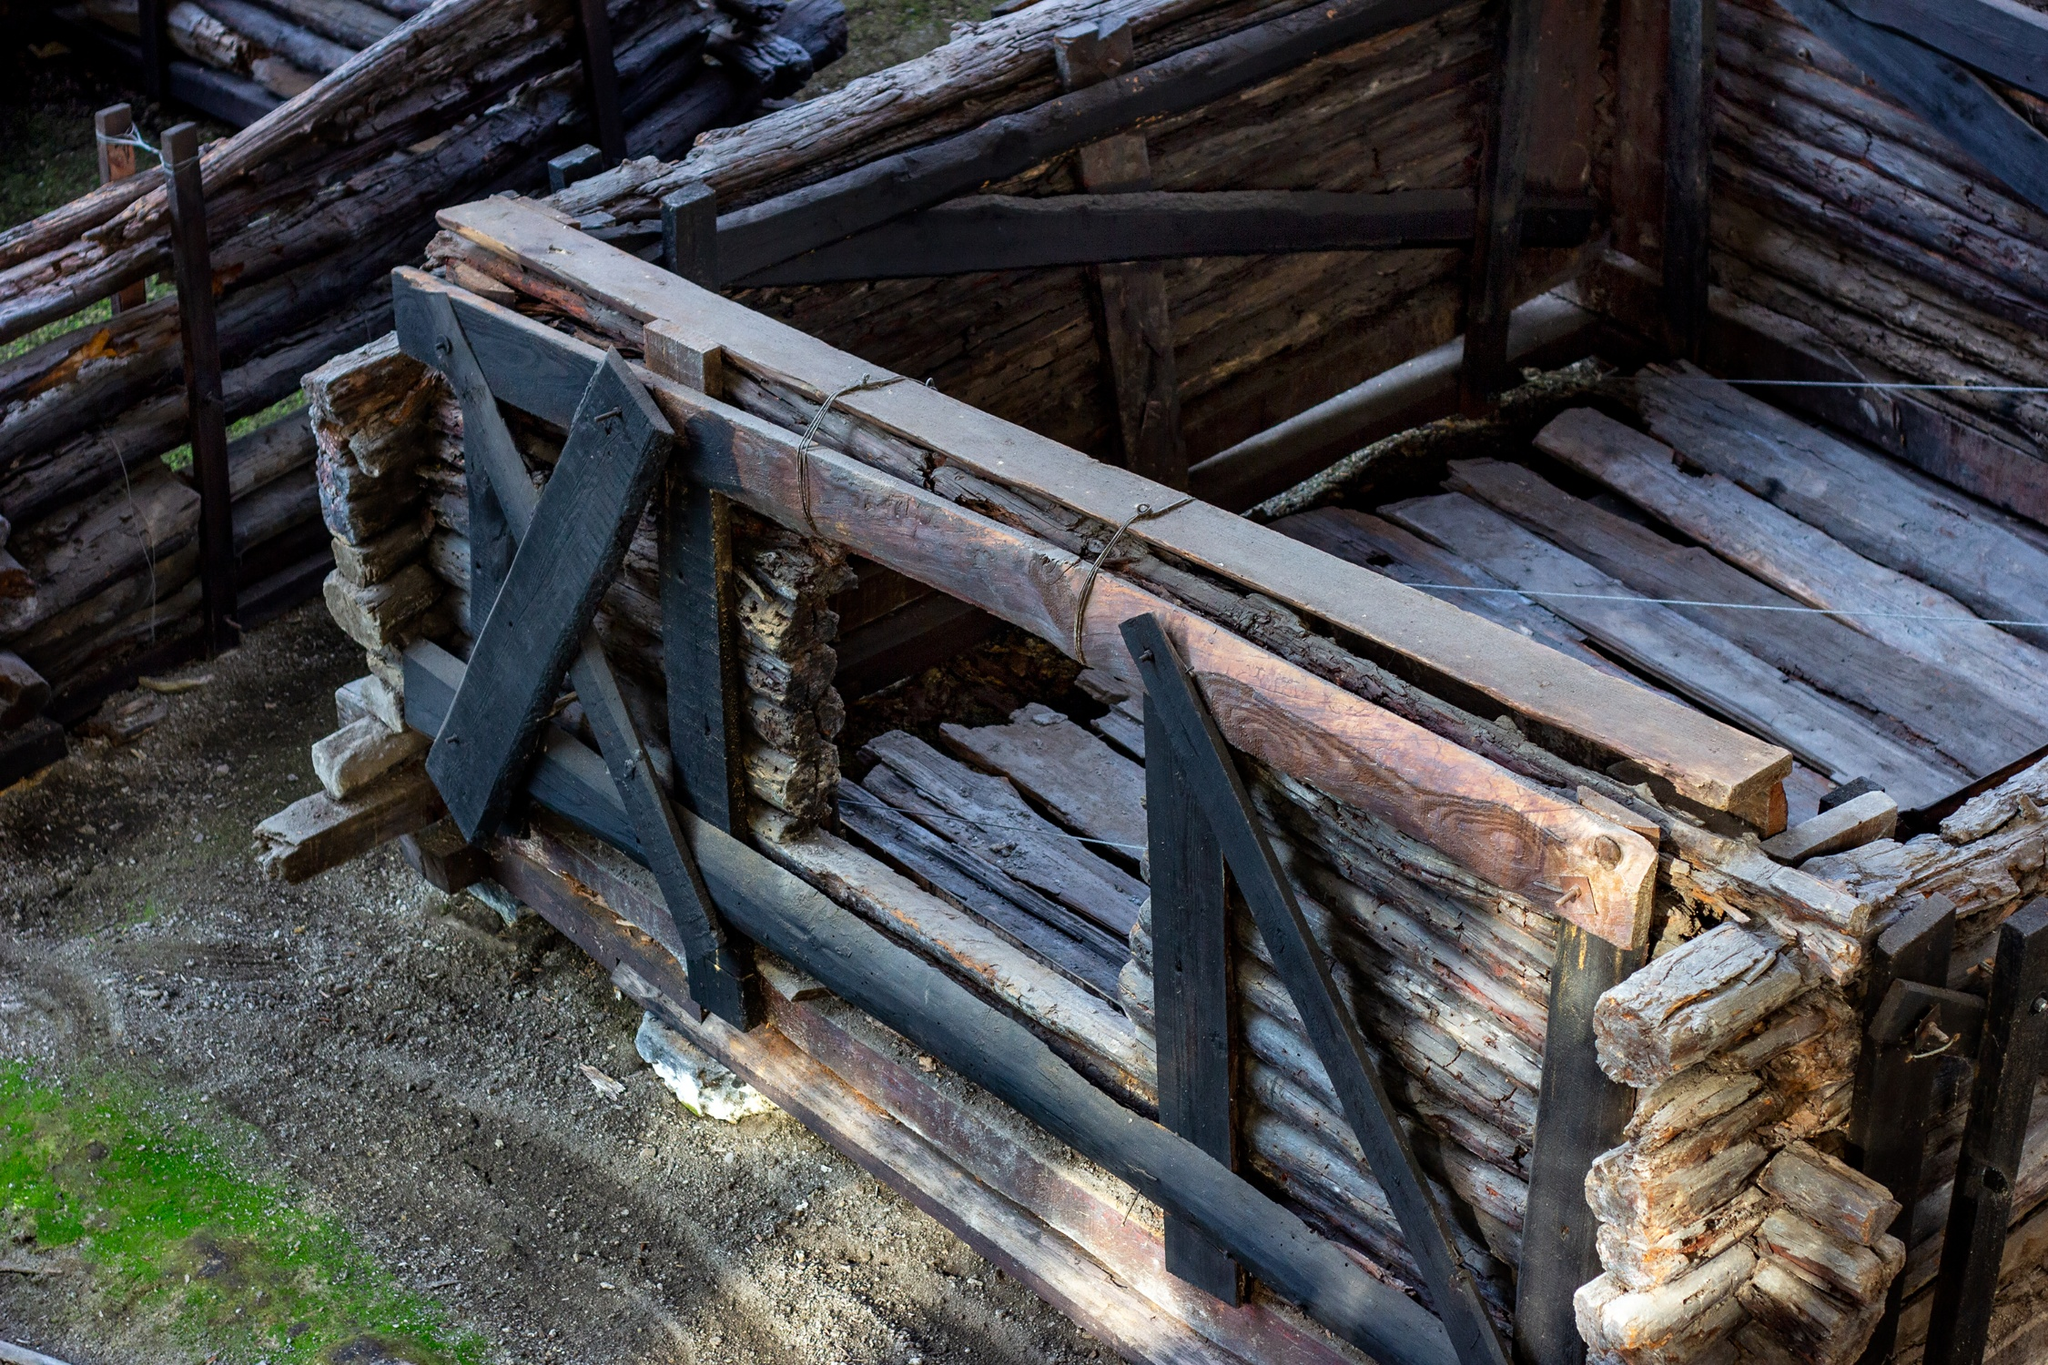What purpose do you think this bridge served in its prime, and how might that have changed today? Originally, this bridge may have served as an essential crossing point over a stream or river, facilitating easier access for locals, perhaps in a rural community. Over time, as the water source receded or dried up, the bridge's utilitarian function likely diminished, turning it into more of a historical artifact or a scenic spot for visitors and hikers, offering a glimpse into the past and a tranquil place to enjoy natural beauty. 